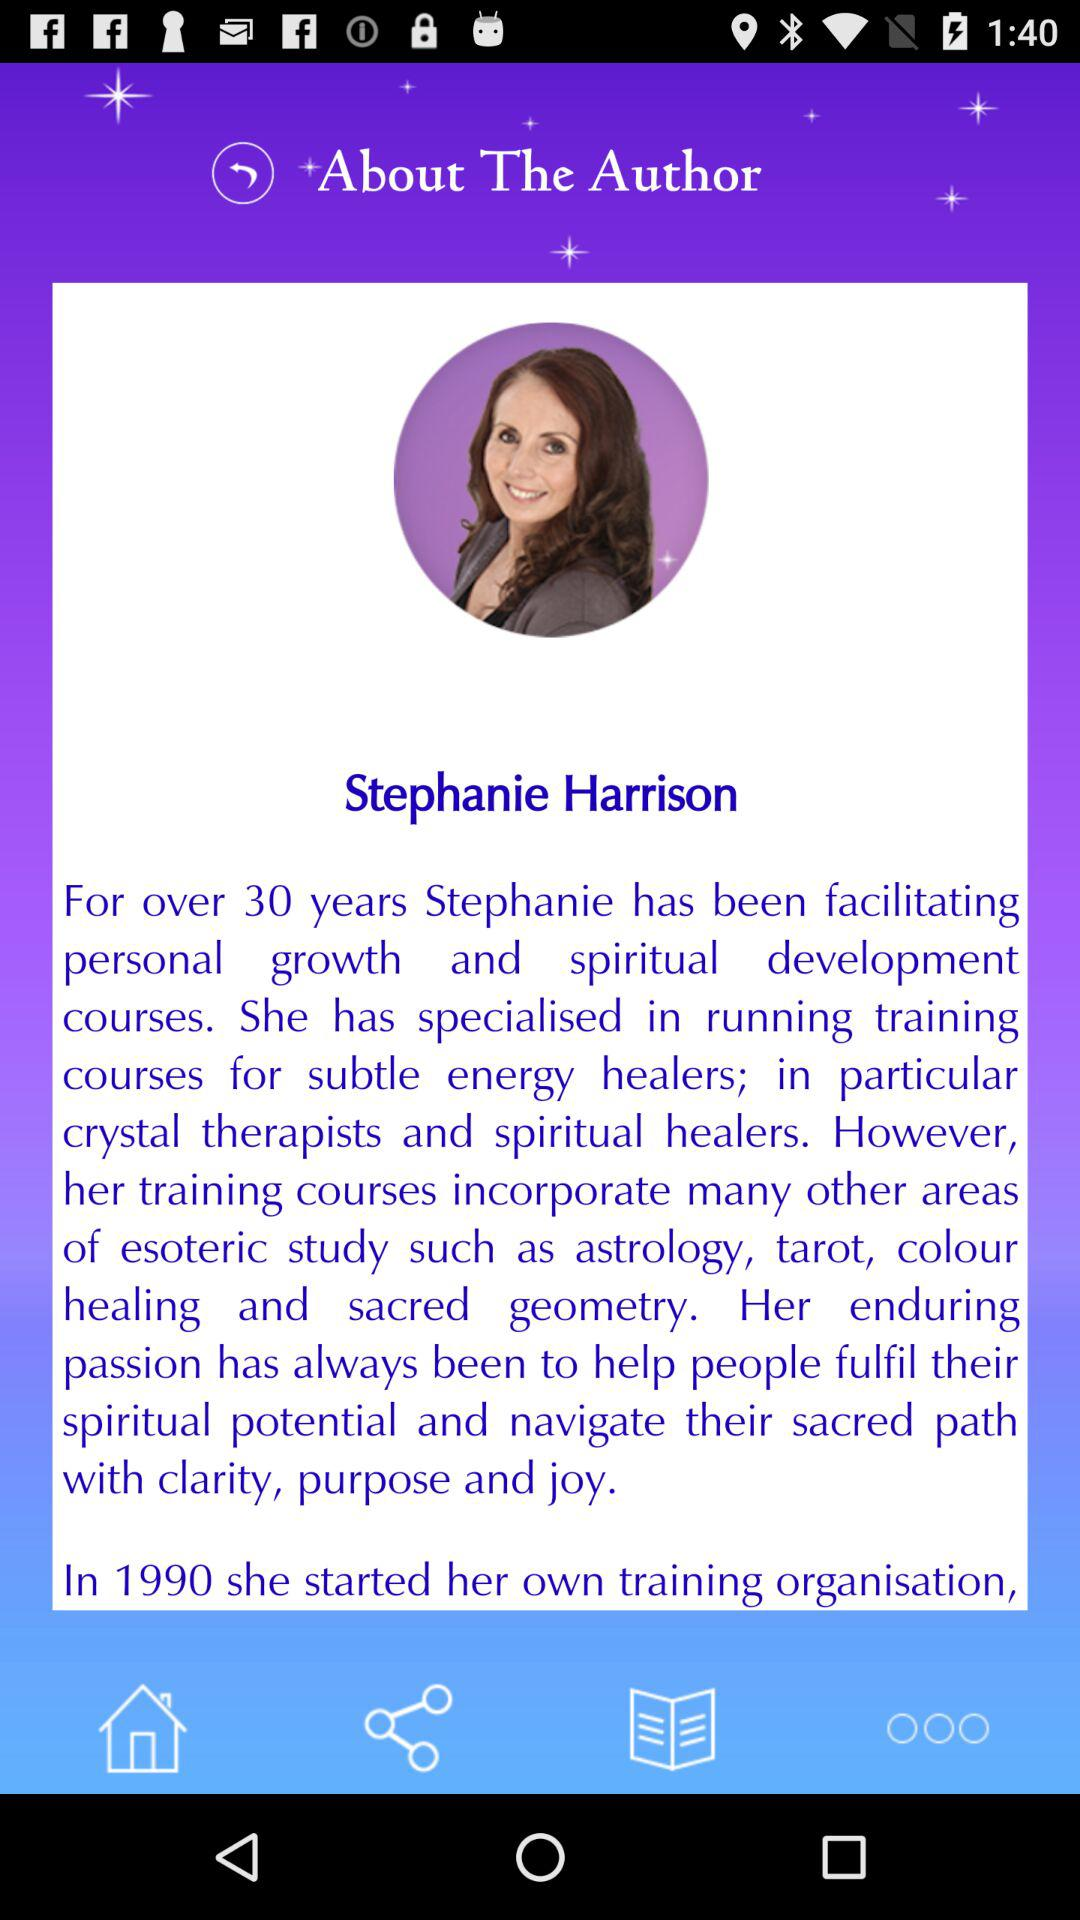How old is Stephanie Harrison?
When the provided information is insufficient, respond with <no answer>. <no answer> 